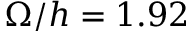Convert formula to latex. <formula><loc_0><loc_0><loc_500><loc_500>\Omega / h = 1 . 9 2</formula> 